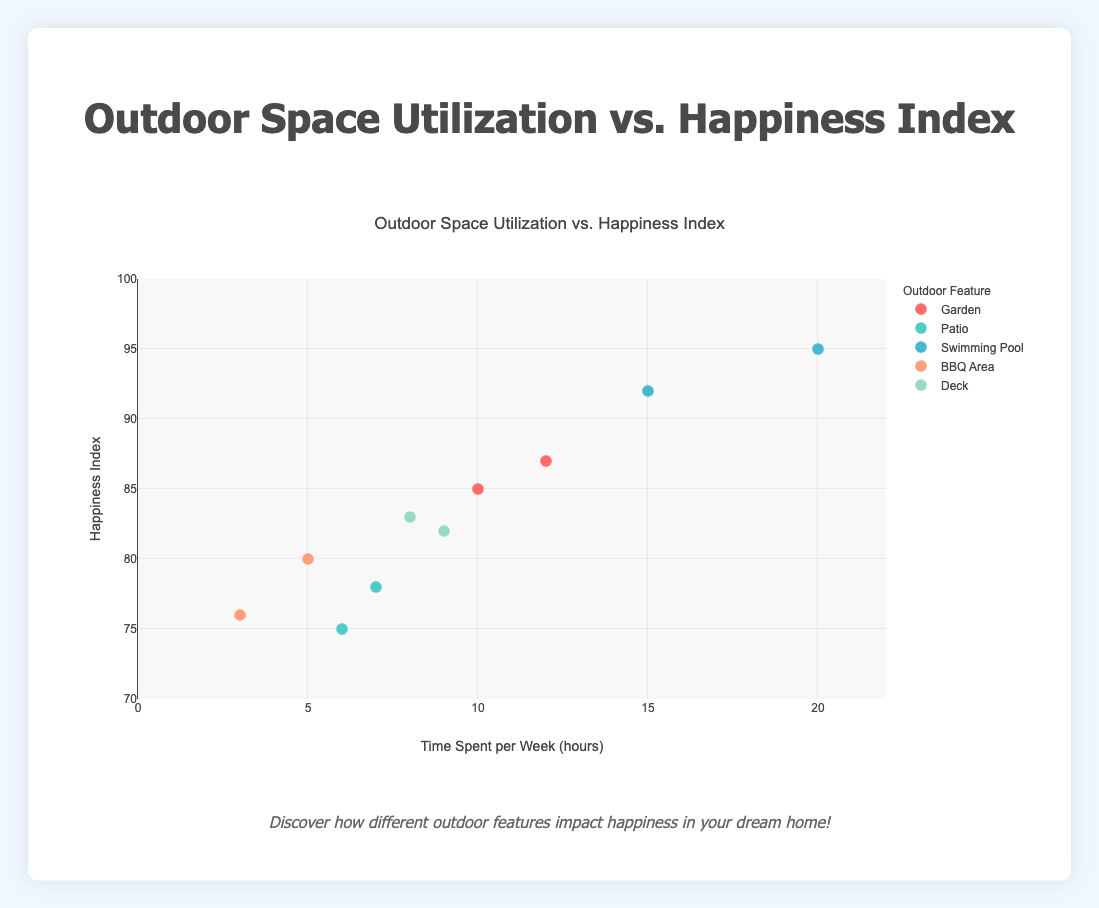What is the title of the plot? The title of the plot is typically found at the top-center of the chart. In this case, the title is clearly stated at the top.
Answer: Outdoor Space Utilization vs. Happiness Index How many data points are related to homes with a "Garden"? To find the number of data points for homes with a "Garden", look for the number of markers associated with the "Garden" outdoor feature in the legend and plot.
Answer: 2 Which outdoor feature has the highest time spent per week? Check the x-axis values of all data points and identify which outdoor feature corresponds to the maximum value.
Answer: Swimming Pool (20 hours) What is the average happiness index for homes with a Patio? Identify the data points for homes with a Patio, sum up their happiness index values, and divide by the number of data points. Calculation: (78 + 75) / 2 = 76.5
Answer: 76.5 Which home owner combination has the highest happiness index? Review the highest y-axis value and identify the corresponding home owner from the hover text or data points.
Answer: Nancy and Steve Lee Between homes with a Deck and a BBQ Area, which has the higher average happiness index? Calculate the average happiness index for each group. Deck: (83 + 82) / 2 = 82.5. BBQ Area: (80 + 76) / 2 = 78.
Answer: Deck Which outdoor feature shows the lowest happiness index for the time spent per week? Identify the data points by outdoor feature and find the lowest y-axis value for each.
Answer: BBQ Area (3 hours, index 76) What is the maximum happiness index for homes with a Swimming Pool? Find the y-axis values for data points related to Swimming Pool and identify the maximum value.
Answer: 95 Does more time spent per week in a Garden correlate with a higher happiness index for the home owners? Compare the two data points for Garden and check if the one with more time spent has a higher happiness index.
Answer: Yes (12 hours, index 87 vs. 10 hours, index 85) Which has a larger range of happiness index values, homes with a Garden or homes with a Patio? Determine the range by subtracting the minimum happiness index value from the maximum for each feature. Garden: 87 - 85 = 2. Patio: 78 - 75 = 3.
Answer: Patio 